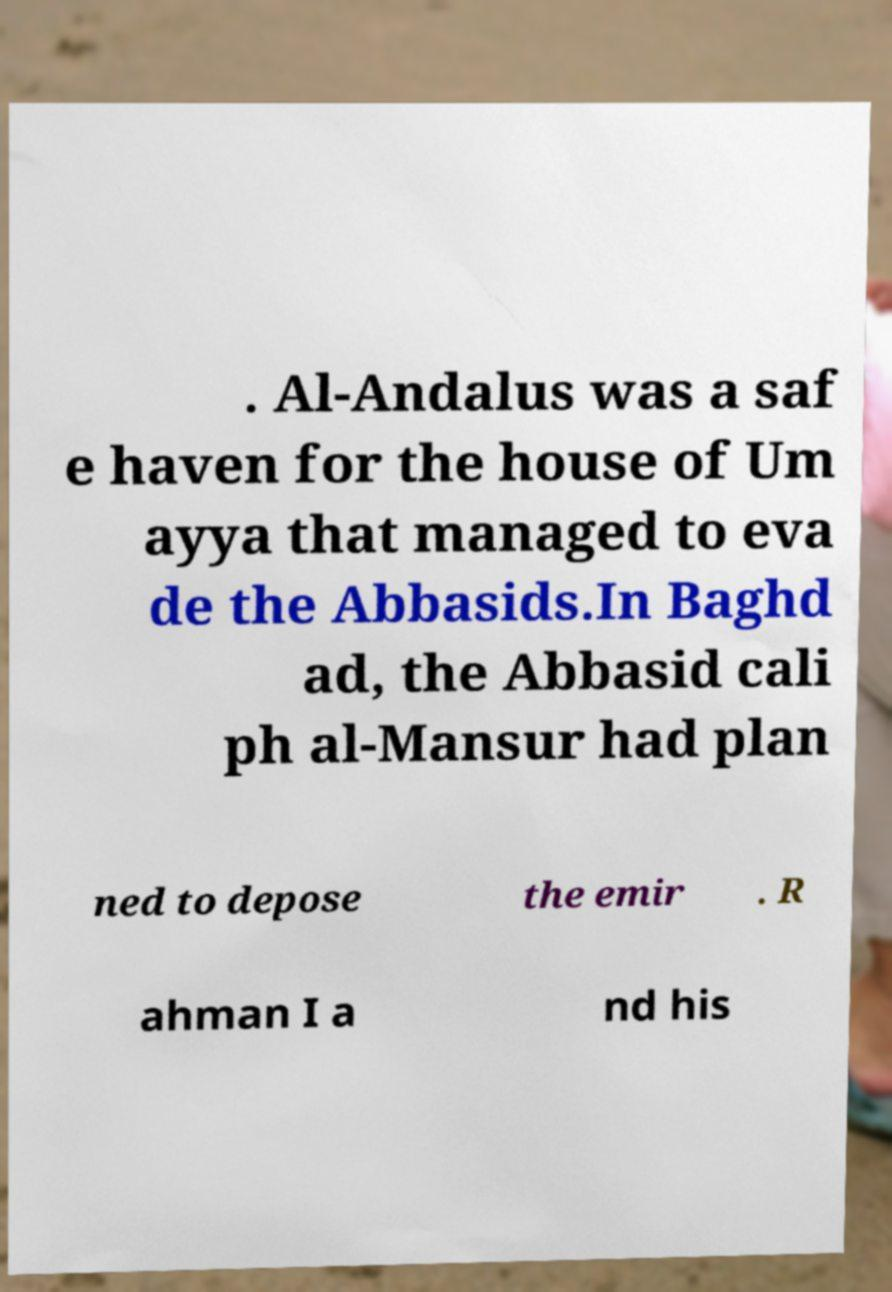Can you read and provide the text displayed in the image?This photo seems to have some interesting text. Can you extract and type it out for me? . Al-Andalus was a saf e haven for the house of Um ayya that managed to eva de the Abbasids.In Baghd ad, the Abbasid cali ph al-Mansur had plan ned to depose the emir . R ahman I a nd his 